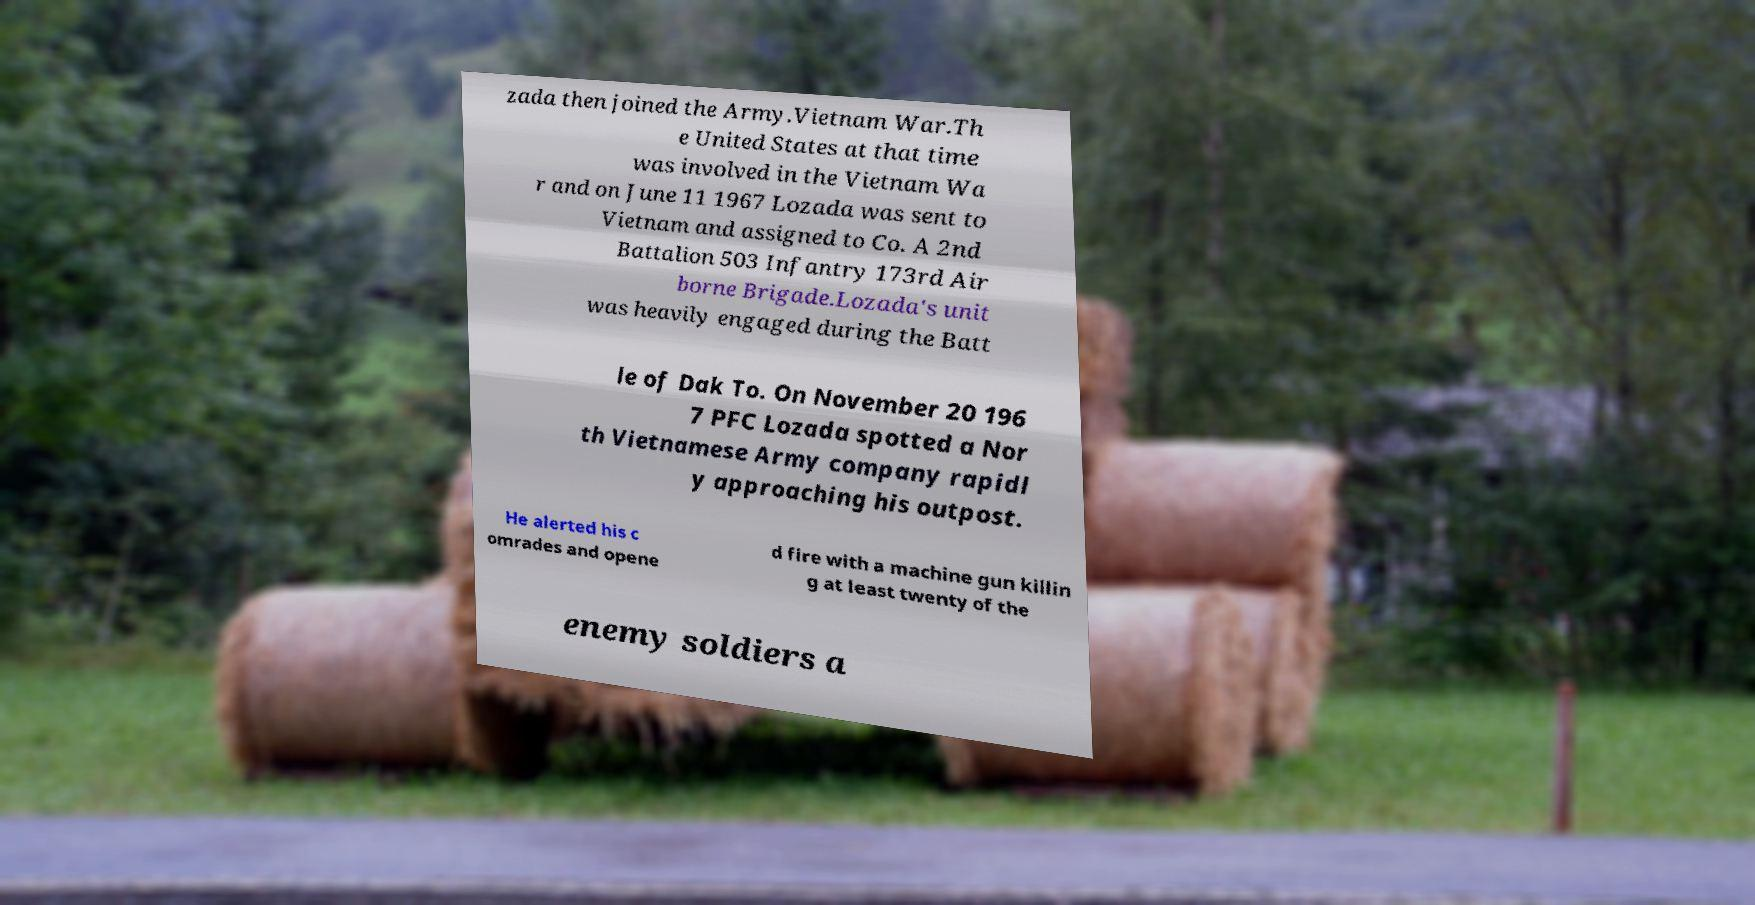Can you read and provide the text displayed in the image?This photo seems to have some interesting text. Can you extract and type it out for me? zada then joined the Army.Vietnam War.Th e United States at that time was involved in the Vietnam Wa r and on June 11 1967 Lozada was sent to Vietnam and assigned to Co. A 2nd Battalion 503 Infantry 173rd Air borne Brigade.Lozada's unit was heavily engaged during the Batt le of Dak To. On November 20 196 7 PFC Lozada spotted a Nor th Vietnamese Army company rapidl y approaching his outpost. He alerted his c omrades and opene d fire with a machine gun killin g at least twenty of the enemy soldiers a 